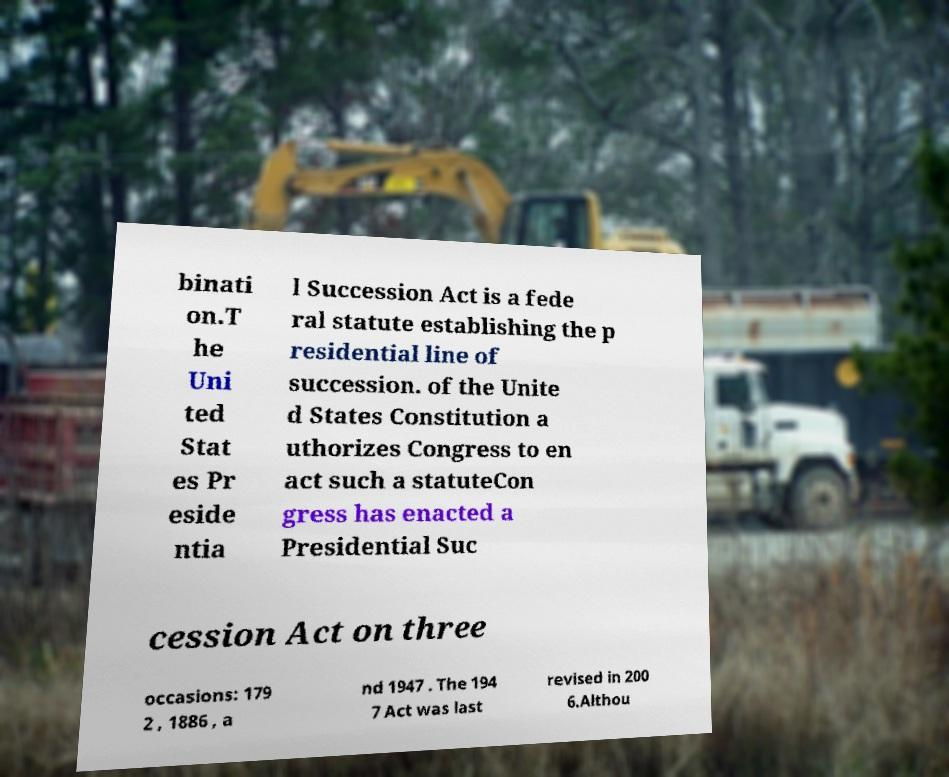Could you assist in decoding the text presented in this image and type it out clearly? binati on.T he Uni ted Stat es Pr eside ntia l Succession Act is a fede ral statute establishing the p residential line of succession. of the Unite d States Constitution a uthorizes Congress to en act such a statuteCon gress has enacted a Presidential Suc cession Act on three occasions: 179 2 , 1886 , a nd 1947 . The 194 7 Act was last revised in 200 6.Althou 